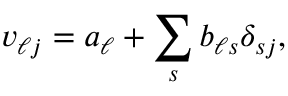<formula> <loc_0><loc_0><loc_500><loc_500>v _ { \ell j } = a _ { \ell } + \sum _ { s } b _ { \ell s } \delta _ { s j } ,</formula> 